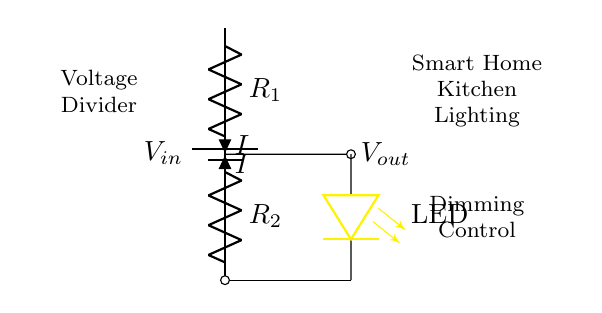What is the role of the resistors in this circuit? The resistors, R1 and R2, form the voltage divider, which reduces the input voltage. They achieve this by dividing the voltage based on their resistance values in relation to each other.
Answer: voltage divider What is the output voltage measured across? The output voltage, Vout, is measured across R2. This is where the dimming control for the LED lighting is applied, allowing adjustment of the LED brightness based on the voltage drop across R2.
Answer: R2 How does increasing R1 affect the LED brightness? Increasing R1 increases the resistance of the top part of the voltage divider, which results in a higher voltage drop across R2. Therefore, less voltage is available for the LED, dimming its brightness.
Answer: LED dimming What type of component is used to represent the lighting? The circuit uses an LED, which is shown in the diagram as a labeled yellow component. LEDs are commonly used in lighting applications and can be dimmed with the voltage divider setup.
Answer: LED What signifies the current flowing through the resistors? The current flowing through the circuit is represented by the letter I, which is shown near both resistors R1 and R2. This indicates the same current flowing through both resistors in series.
Answer: I What is the purpose of the battery in this circuit? The battery provides the input voltage, V_in, necessary to power the LEDs through the voltage divider configuration. It is essential for ensuring the circuit functions as intended.
Answer: power source 